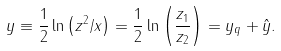<formula> <loc_0><loc_0><loc_500><loc_500>y \equiv \frac { 1 } { 2 } \ln \left ( z ^ { 2 } / x \right ) = \frac { 1 } { 2 } \ln \left ( \frac { z _ { 1 } } { z _ { 2 } } \right ) = y _ { q } + \hat { y } .</formula> 